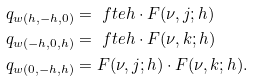<formula> <loc_0><loc_0><loc_500><loc_500>q _ { w ( h , - h , 0 ) } & = \ f t { e } { h } \cdot F ( \nu , j ; h ) \\ q _ { w ( - h , 0 , h ) } & = \ f t { e } { h } \cdot F ( \nu , k ; h ) \\ q _ { w ( 0 , - h , h ) } & = F ( \nu , j ; h ) \cdot F ( \nu , k ; h ) .</formula> 